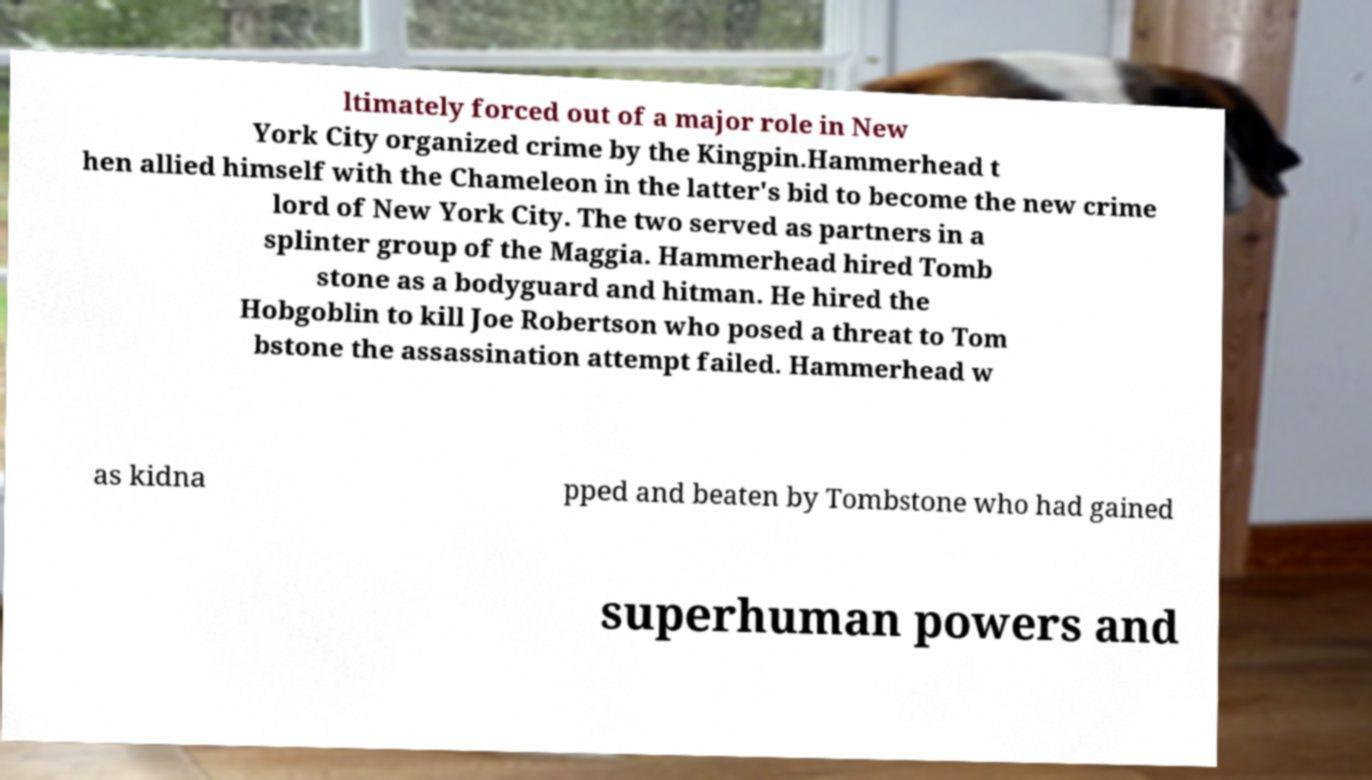For documentation purposes, I need the text within this image transcribed. Could you provide that? ltimately forced out of a major role in New York City organized crime by the Kingpin.Hammerhead t hen allied himself with the Chameleon in the latter's bid to become the new crime lord of New York City. The two served as partners in a splinter group of the Maggia. Hammerhead hired Tomb stone as a bodyguard and hitman. He hired the Hobgoblin to kill Joe Robertson who posed a threat to Tom bstone the assassination attempt failed. Hammerhead w as kidna pped and beaten by Tombstone who had gained superhuman powers and 